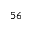Convert formula to latex. <formula><loc_0><loc_0><loc_500><loc_500>^ { 5 6 }</formula> 